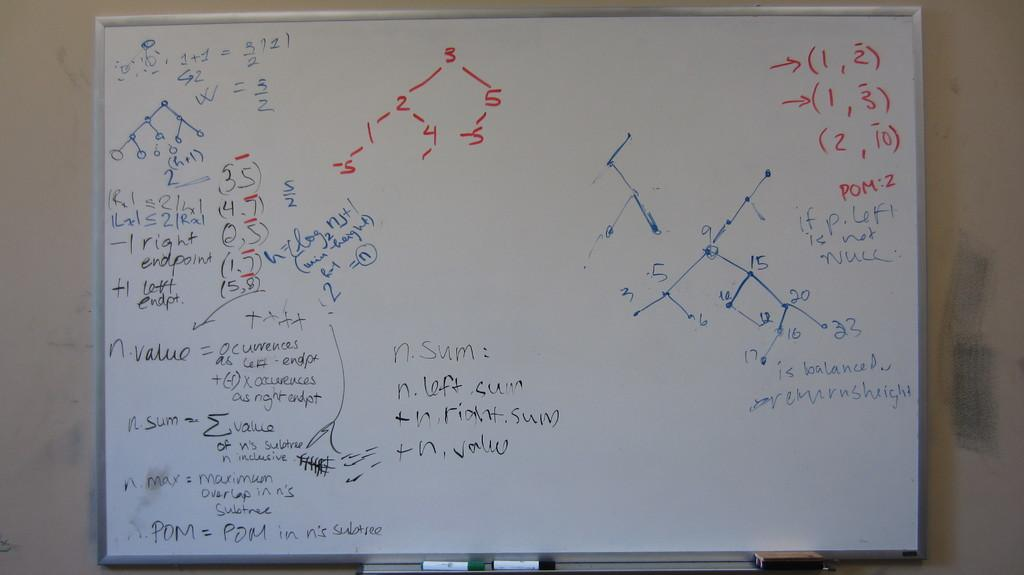<image>
Render a clear and concise summary of the photo. A A whiteboard showing multiple algebra equations with multiple points and steps. 